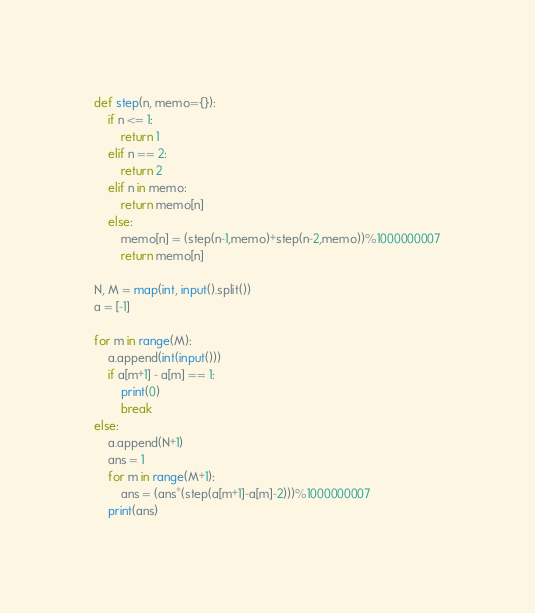<code> <loc_0><loc_0><loc_500><loc_500><_Python_>def step(n, memo={}):
    if n <= 1:
        return 1
    elif n == 2:
        return 2
    elif n in memo:
        return memo[n]
    else:
        memo[n] = (step(n-1,memo)+step(n-2,memo))%1000000007
        return memo[n]

N, M = map(int, input().split())
a = [-1]

for m in range(M):
    a.append(int(input()))
    if a[m+1] - a[m] == 1:
        print(0)
        break
else:
    a.append(N+1)
    ans = 1
    for m in range(M+1):
        ans = (ans*(step(a[m+1]-a[m]-2)))%1000000007
    print(ans)</code> 